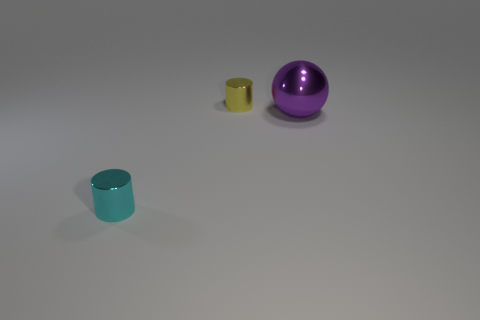Add 1 tiny cyan rubber spheres. How many objects exist? 4 Subtract all spheres. How many objects are left? 2 Subtract 0 gray balls. How many objects are left? 3 Subtract all large brown metal things. Subtract all large shiny objects. How many objects are left? 2 Add 1 small things. How many small things are left? 3 Add 2 tiny yellow shiny objects. How many tiny yellow shiny objects exist? 3 